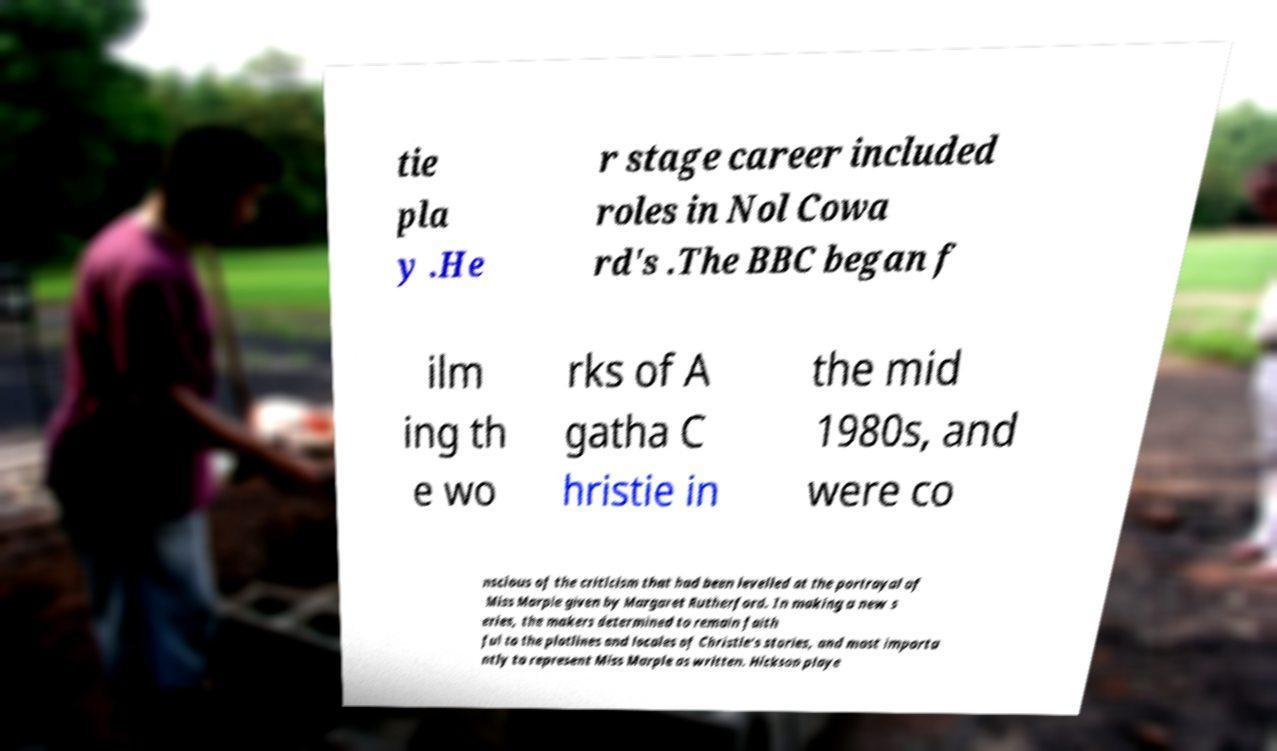There's text embedded in this image that I need extracted. Can you transcribe it verbatim? tie pla y .He r stage career included roles in Nol Cowa rd's .The BBC began f ilm ing th e wo rks of A gatha C hristie in the mid 1980s, and were co nscious of the criticism that had been levelled at the portrayal of Miss Marple given by Margaret Rutherford. In making a new s eries, the makers determined to remain faith ful to the plotlines and locales of Christie's stories, and most importa ntly to represent Miss Marple as written. Hickson playe 